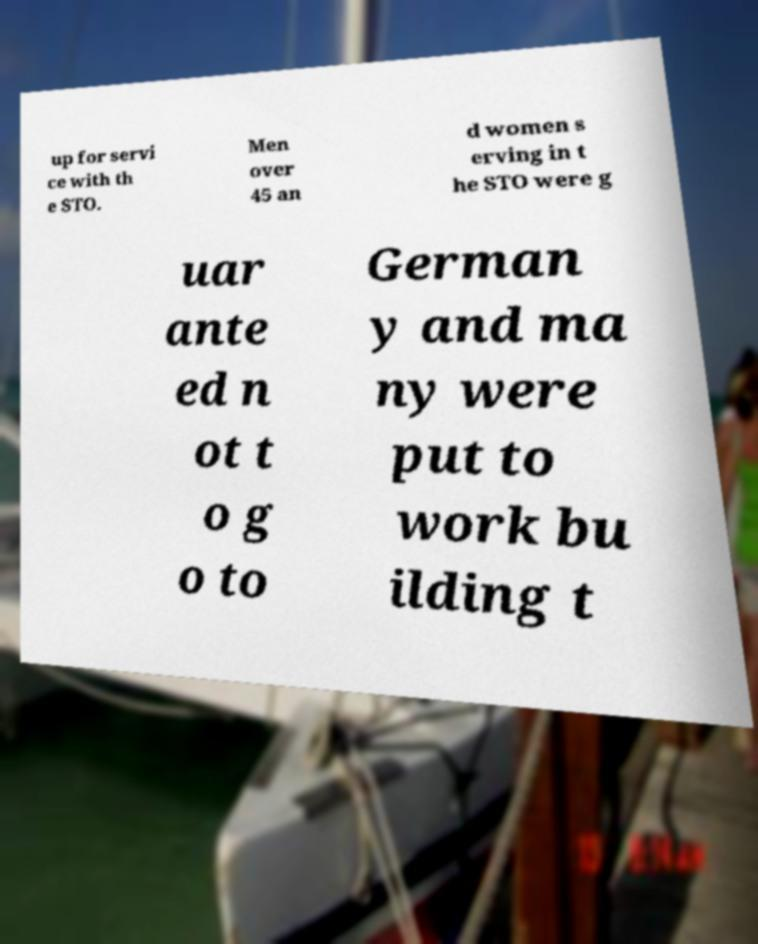Can you read and provide the text displayed in the image?This photo seems to have some interesting text. Can you extract and type it out for me? up for servi ce with th e STO. Men over 45 an d women s erving in t he STO were g uar ante ed n ot t o g o to German y and ma ny were put to work bu ilding t 